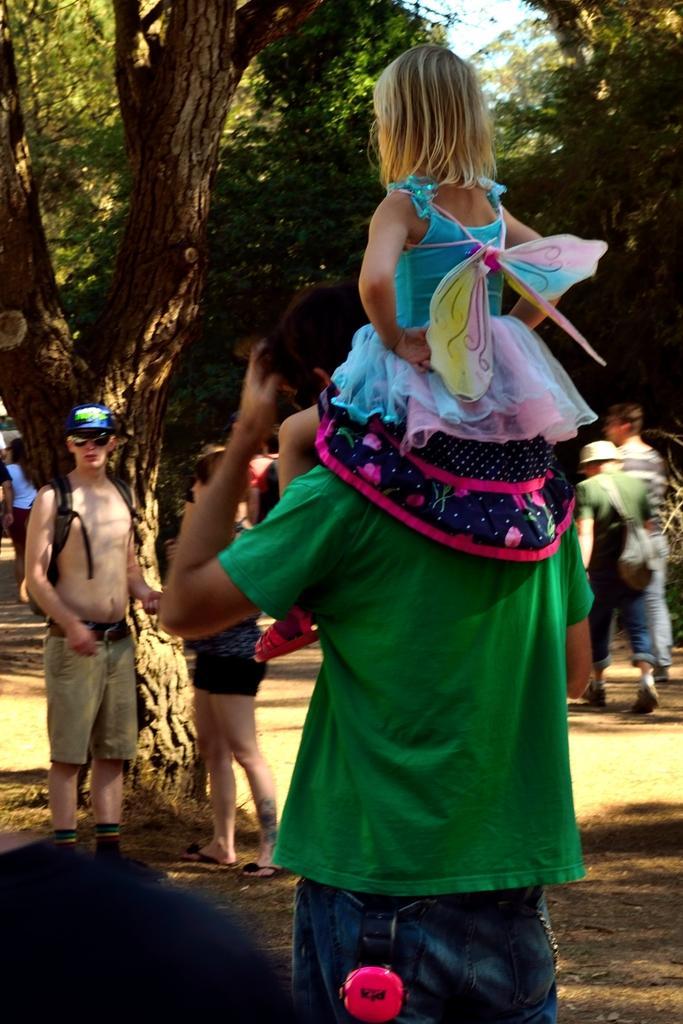Please provide a concise description of this image. In this picture we can see some people are standing, on the right side there is a person walking, a person in the front is carrying a kid, in the background there are some trees, we can see the sky at the top of the picture. 